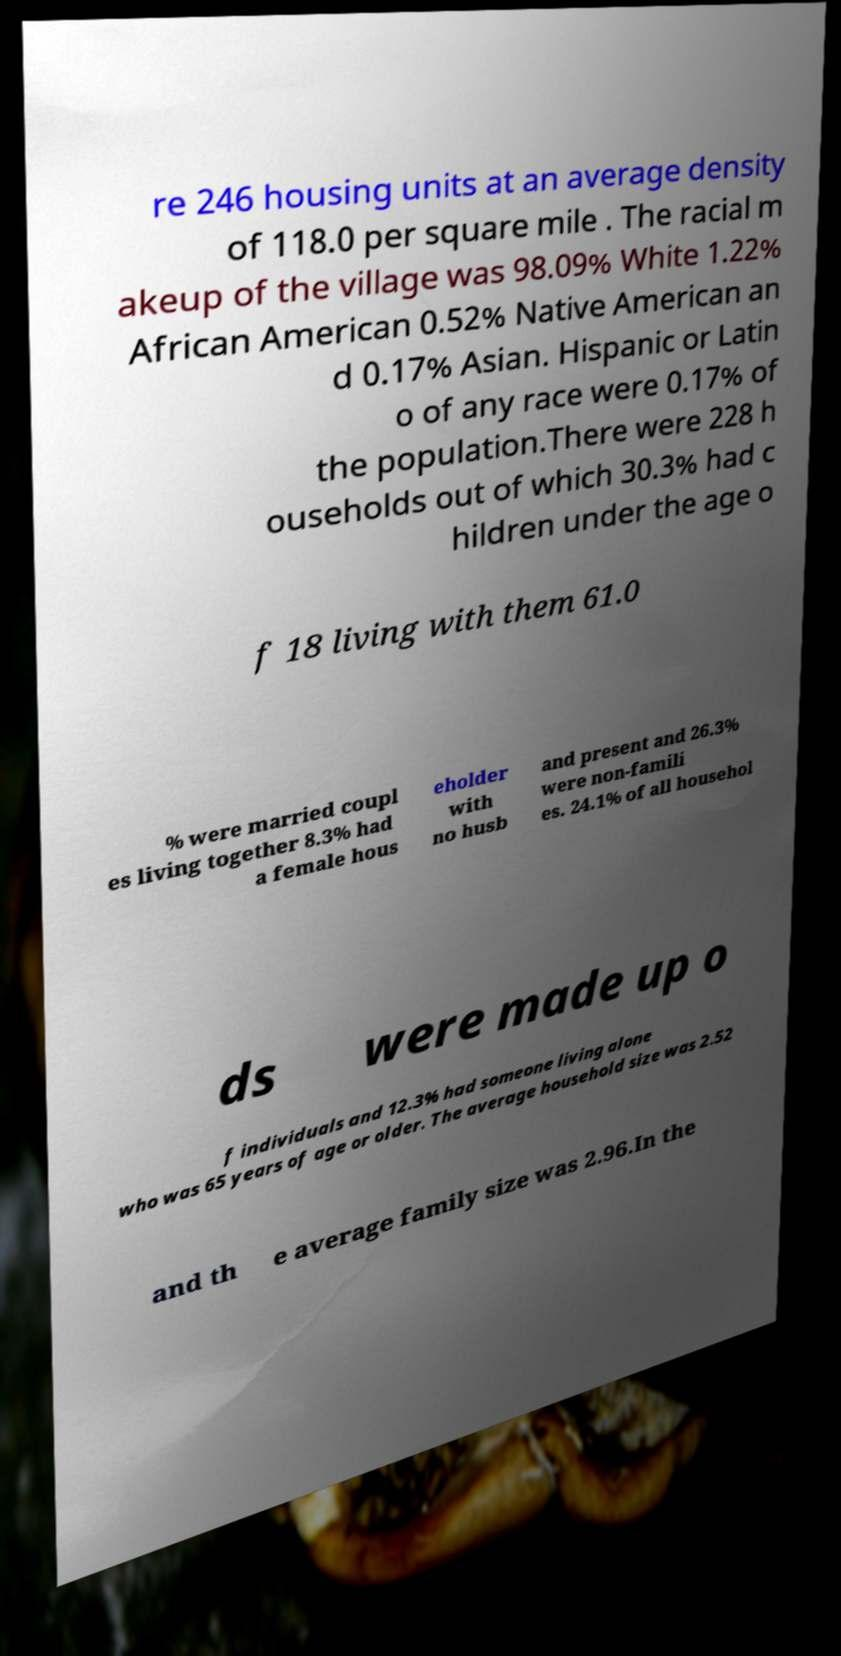Please read and relay the text visible in this image. What does it say? re 246 housing units at an average density of 118.0 per square mile . The racial m akeup of the village was 98.09% White 1.22% African American 0.52% Native American an d 0.17% Asian. Hispanic or Latin o of any race were 0.17% of the population.There were 228 h ouseholds out of which 30.3% had c hildren under the age o f 18 living with them 61.0 % were married coupl es living together 8.3% had a female hous eholder with no husb and present and 26.3% were non-famili es. 24.1% of all househol ds were made up o f individuals and 12.3% had someone living alone who was 65 years of age or older. The average household size was 2.52 and th e average family size was 2.96.In the 